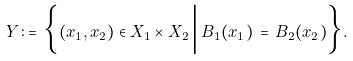<formula> <loc_0><loc_0><loc_500><loc_500>Y \, \colon = \, \Big \{ ( x _ { 1 } , x _ { 2 } ) \in X _ { 1 } \times X _ { 2 } \, \Big | \, B _ { 1 } ( x _ { 1 } ) \, = \, B _ { 2 } ( x _ { 2 } ) \Big \} .</formula> 